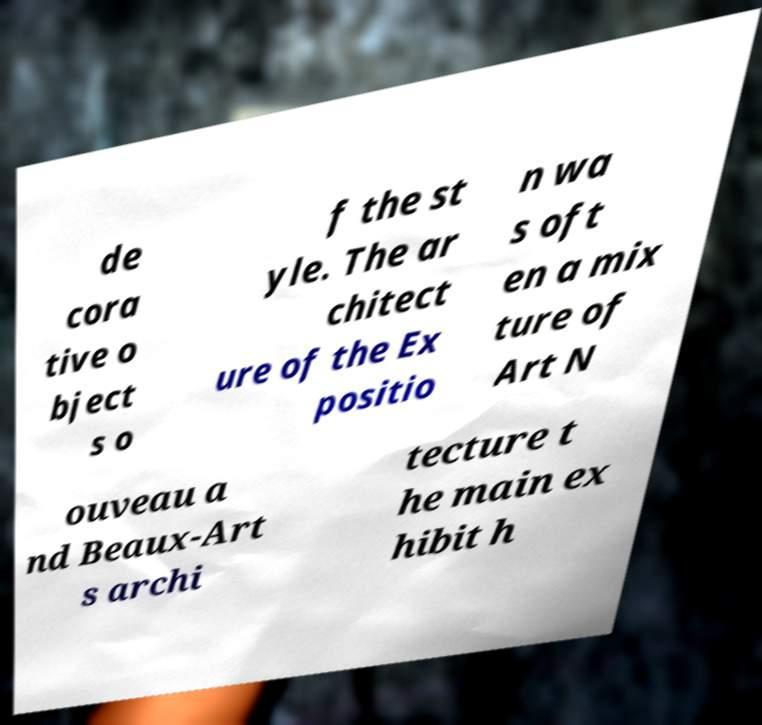I need the written content from this picture converted into text. Can you do that? de cora tive o bject s o f the st yle. The ar chitect ure of the Ex positio n wa s oft en a mix ture of Art N ouveau a nd Beaux-Art s archi tecture t he main ex hibit h 